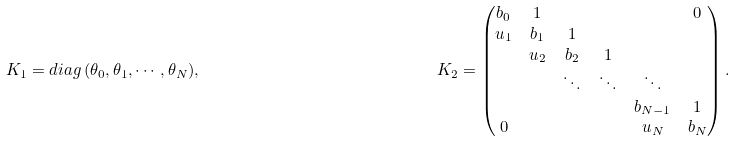Convert formula to latex. <formula><loc_0><loc_0><loc_500><loc_500>K _ { 1 } = d i a g \, ( \theta _ { 0 } , \theta _ { 1 } , \cdots , \theta _ { N } ) , & & K _ { 2 } = \begin{pmatrix} b _ { 0 } & 1 & & & & 0 \\ u _ { 1 } & b _ { 1 } & 1 & & \\ & u _ { 2 } & b _ { 2 } & 1 & & \\ & & \ddots & \ddots & \ddots & \\ & & & & b _ { N - 1 } & 1 \\ 0 & & & & u _ { N } & b _ { N } \end{pmatrix} .</formula> 